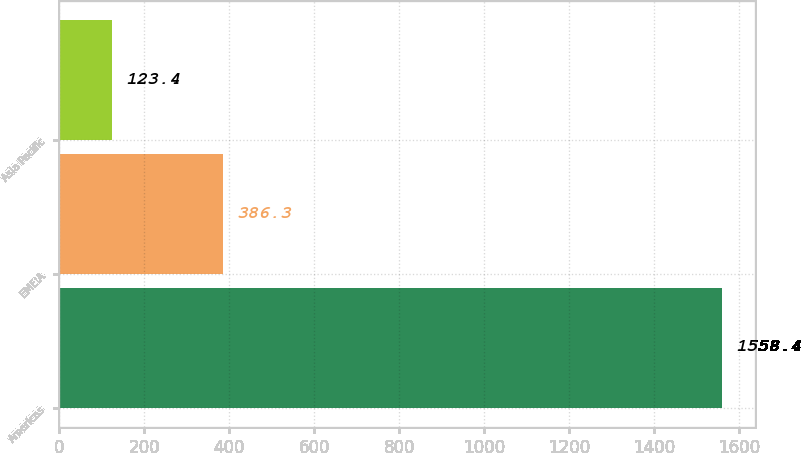Convert chart to OTSL. <chart><loc_0><loc_0><loc_500><loc_500><bar_chart><fcel>Americas<fcel>EMEIA<fcel>Asia Pacific<nl><fcel>1558.4<fcel>386.3<fcel>123.4<nl></chart> 